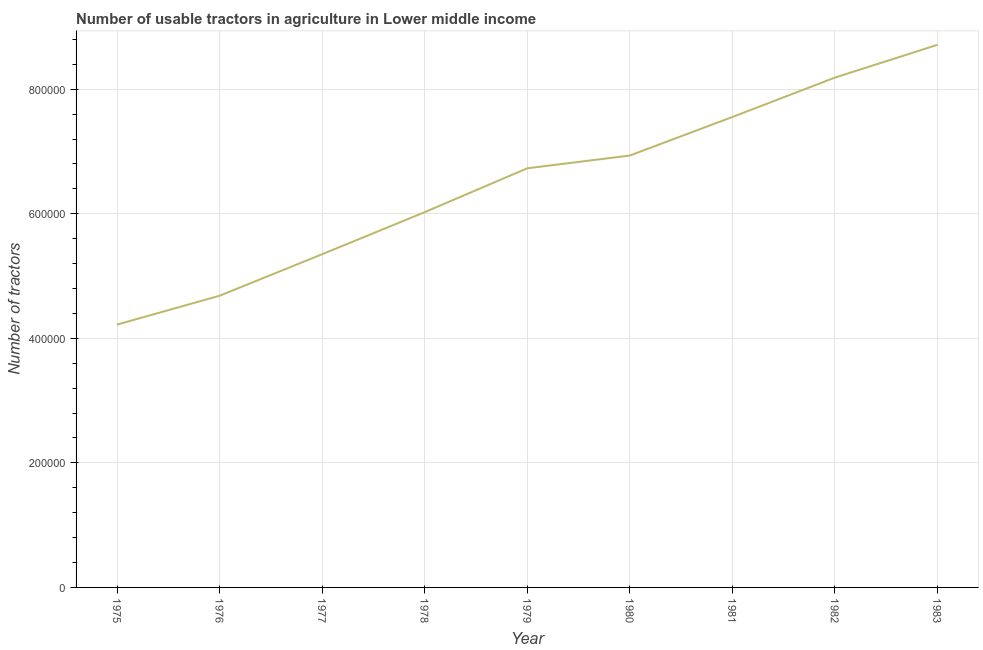What is the number of tractors in 1976?
Provide a short and direct response. 4.68e+05. Across all years, what is the maximum number of tractors?
Your response must be concise. 8.71e+05. Across all years, what is the minimum number of tractors?
Offer a terse response. 4.22e+05. In which year was the number of tractors minimum?
Make the answer very short. 1975. What is the sum of the number of tractors?
Your response must be concise. 5.84e+06. What is the difference between the number of tractors in 1975 and 1976?
Your answer should be compact. -4.64e+04. What is the average number of tractors per year?
Ensure brevity in your answer.  6.49e+05. What is the median number of tractors?
Your response must be concise. 6.73e+05. In how many years, is the number of tractors greater than 560000 ?
Your answer should be compact. 6. Do a majority of the years between 1979 and 1981 (inclusive) have number of tractors greater than 480000 ?
Ensure brevity in your answer.  Yes. What is the ratio of the number of tractors in 1976 to that in 1980?
Keep it short and to the point. 0.68. Is the number of tractors in 1979 less than that in 1983?
Provide a short and direct response. Yes. Is the difference between the number of tractors in 1976 and 1979 greater than the difference between any two years?
Make the answer very short. No. What is the difference between the highest and the second highest number of tractors?
Keep it short and to the point. 5.27e+04. What is the difference between the highest and the lowest number of tractors?
Your answer should be compact. 4.49e+05. How many lines are there?
Your answer should be very brief. 1. How many years are there in the graph?
Make the answer very short. 9. What is the difference between two consecutive major ticks on the Y-axis?
Make the answer very short. 2.00e+05. Does the graph contain any zero values?
Make the answer very short. No. What is the title of the graph?
Your answer should be compact. Number of usable tractors in agriculture in Lower middle income. What is the label or title of the X-axis?
Ensure brevity in your answer.  Year. What is the label or title of the Y-axis?
Offer a terse response. Number of tractors. What is the Number of tractors in 1975?
Your answer should be very brief. 4.22e+05. What is the Number of tractors of 1976?
Offer a very short reply. 4.68e+05. What is the Number of tractors in 1977?
Your answer should be very brief. 5.35e+05. What is the Number of tractors in 1978?
Make the answer very short. 6.03e+05. What is the Number of tractors in 1979?
Provide a short and direct response. 6.73e+05. What is the Number of tractors of 1980?
Your response must be concise. 6.94e+05. What is the Number of tractors in 1981?
Offer a very short reply. 7.55e+05. What is the Number of tractors in 1982?
Your answer should be very brief. 8.19e+05. What is the Number of tractors of 1983?
Your answer should be compact. 8.71e+05. What is the difference between the Number of tractors in 1975 and 1976?
Your answer should be very brief. -4.64e+04. What is the difference between the Number of tractors in 1975 and 1977?
Offer a very short reply. -1.13e+05. What is the difference between the Number of tractors in 1975 and 1978?
Make the answer very short. -1.81e+05. What is the difference between the Number of tractors in 1975 and 1979?
Your answer should be very brief. -2.51e+05. What is the difference between the Number of tractors in 1975 and 1980?
Your response must be concise. -2.72e+05. What is the difference between the Number of tractors in 1975 and 1981?
Offer a terse response. -3.33e+05. What is the difference between the Number of tractors in 1975 and 1982?
Your response must be concise. -3.97e+05. What is the difference between the Number of tractors in 1975 and 1983?
Make the answer very short. -4.49e+05. What is the difference between the Number of tractors in 1976 and 1977?
Give a very brief answer. -6.66e+04. What is the difference between the Number of tractors in 1976 and 1978?
Ensure brevity in your answer.  -1.34e+05. What is the difference between the Number of tractors in 1976 and 1979?
Give a very brief answer. -2.05e+05. What is the difference between the Number of tractors in 1976 and 1980?
Make the answer very short. -2.25e+05. What is the difference between the Number of tractors in 1976 and 1981?
Your answer should be compact. -2.87e+05. What is the difference between the Number of tractors in 1976 and 1982?
Provide a succinct answer. -3.50e+05. What is the difference between the Number of tractors in 1976 and 1983?
Provide a short and direct response. -4.03e+05. What is the difference between the Number of tractors in 1977 and 1978?
Offer a very short reply. -6.76e+04. What is the difference between the Number of tractors in 1977 and 1979?
Your answer should be compact. -1.38e+05. What is the difference between the Number of tractors in 1977 and 1980?
Offer a very short reply. -1.59e+05. What is the difference between the Number of tractors in 1977 and 1981?
Make the answer very short. -2.20e+05. What is the difference between the Number of tractors in 1977 and 1982?
Your response must be concise. -2.84e+05. What is the difference between the Number of tractors in 1977 and 1983?
Your answer should be very brief. -3.36e+05. What is the difference between the Number of tractors in 1978 and 1979?
Provide a succinct answer. -7.04e+04. What is the difference between the Number of tractors in 1978 and 1980?
Your response must be concise. -9.09e+04. What is the difference between the Number of tractors in 1978 and 1981?
Provide a succinct answer. -1.53e+05. What is the difference between the Number of tractors in 1978 and 1982?
Your answer should be very brief. -2.16e+05. What is the difference between the Number of tractors in 1978 and 1983?
Your answer should be compact. -2.69e+05. What is the difference between the Number of tractors in 1979 and 1980?
Ensure brevity in your answer.  -2.05e+04. What is the difference between the Number of tractors in 1979 and 1981?
Your answer should be very brief. -8.24e+04. What is the difference between the Number of tractors in 1979 and 1982?
Provide a succinct answer. -1.46e+05. What is the difference between the Number of tractors in 1979 and 1983?
Your answer should be very brief. -1.98e+05. What is the difference between the Number of tractors in 1980 and 1981?
Keep it short and to the point. -6.19e+04. What is the difference between the Number of tractors in 1980 and 1982?
Make the answer very short. -1.25e+05. What is the difference between the Number of tractors in 1980 and 1983?
Provide a succinct answer. -1.78e+05. What is the difference between the Number of tractors in 1981 and 1982?
Make the answer very short. -6.33e+04. What is the difference between the Number of tractors in 1981 and 1983?
Make the answer very short. -1.16e+05. What is the difference between the Number of tractors in 1982 and 1983?
Offer a terse response. -5.27e+04. What is the ratio of the Number of tractors in 1975 to that in 1976?
Offer a very short reply. 0.9. What is the ratio of the Number of tractors in 1975 to that in 1977?
Make the answer very short. 0.79. What is the ratio of the Number of tractors in 1975 to that in 1978?
Provide a succinct answer. 0.7. What is the ratio of the Number of tractors in 1975 to that in 1979?
Your answer should be compact. 0.63. What is the ratio of the Number of tractors in 1975 to that in 1980?
Make the answer very short. 0.61. What is the ratio of the Number of tractors in 1975 to that in 1981?
Give a very brief answer. 0.56. What is the ratio of the Number of tractors in 1975 to that in 1982?
Make the answer very short. 0.52. What is the ratio of the Number of tractors in 1975 to that in 1983?
Give a very brief answer. 0.48. What is the ratio of the Number of tractors in 1976 to that in 1977?
Give a very brief answer. 0.88. What is the ratio of the Number of tractors in 1976 to that in 1978?
Provide a short and direct response. 0.78. What is the ratio of the Number of tractors in 1976 to that in 1979?
Offer a terse response. 0.7. What is the ratio of the Number of tractors in 1976 to that in 1980?
Offer a very short reply. 0.68. What is the ratio of the Number of tractors in 1976 to that in 1981?
Your answer should be compact. 0.62. What is the ratio of the Number of tractors in 1976 to that in 1982?
Make the answer very short. 0.57. What is the ratio of the Number of tractors in 1976 to that in 1983?
Keep it short and to the point. 0.54. What is the ratio of the Number of tractors in 1977 to that in 1978?
Ensure brevity in your answer.  0.89. What is the ratio of the Number of tractors in 1977 to that in 1979?
Your answer should be very brief. 0.8. What is the ratio of the Number of tractors in 1977 to that in 1980?
Make the answer very short. 0.77. What is the ratio of the Number of tractors in 1977 to that in 1981?
Your response must be concise. 0.71. What is the ratio of the Number of tractors in 1977 to that in 1982?
Your response must be concise. 0.65. What is the ratio of the Number of tractors in 1977 to that in 1983?
Ensure brevity in your answer.  0.61. What is the ratio of the Number of tractors in 1978 to that in 1979?
Offer a terse response. 0.9. What is the ratio of the Number of tractors in 1978 to that in 1980?
Offer a very short reply. 0.87. What is the ratio of the Number of tractors in 1978 to that in 1981?
Offer a very short reply. 0.8. What is the ratio of the Number of tractors in 1978 to that in 1982?
Keep it short and to the point. 0.74. What is the ratio of the Number of tractors in 1978 to that in 1983?
Provide a succinct answer. 0.69. What is the ratio of the Number of tractors in 1979 to that in 1981?
Provide a succinct answer. 0.89. What is the ratio of the Number of tractors in 1979 to that in 1982?
Your answer should be compact. 0.82. What is the ratio of the Number of tractors in 1979 to that in 1983?
Your response must be concise. 0.77. What is the ratio of the Number of tractors in 1980 to that in 1981?
Offer a very short reply. 0.92. What is the ratio of the Number of tractors in 1980 to that in 1982?
Your response must be concise. 0.85. What is the ratio of the Number of tractors in 1980 to that in 1983?
Give a very brief answer. 0.8. What is the ratio of the Number of tractors in 1981 to that in 1982?
Keep it short and to the point. 0.92. What is the ratio of the Number of tractors in 1981 to that in 1983?
Your response must be concise. 0.87. What is the ratio of the Number of tractors in 1982 to that in 1983?
Give a very brief answer. 0.94. 